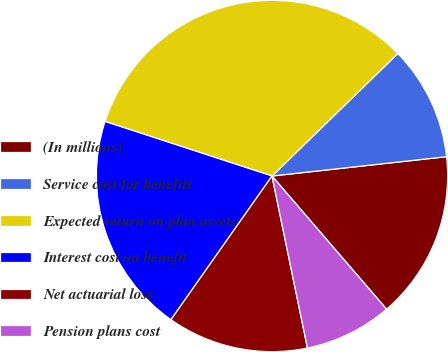Convert chart. <chart><loc_0><loc_0><loc_500><loc_500><pie_chart><fcel>(In millions)<fcel>Service cost for benefits<fcel>Expected return on plan assets<fcel>Interest cost on benefit<fcel>Net actuarial loss<fcel>Pension plans cost<nl><fcel>15.45%<fcel>10.53%<fcel>32.69%<fcel>20.27%<fcel>12.99%<fcel>8.07%<nl></chart> 